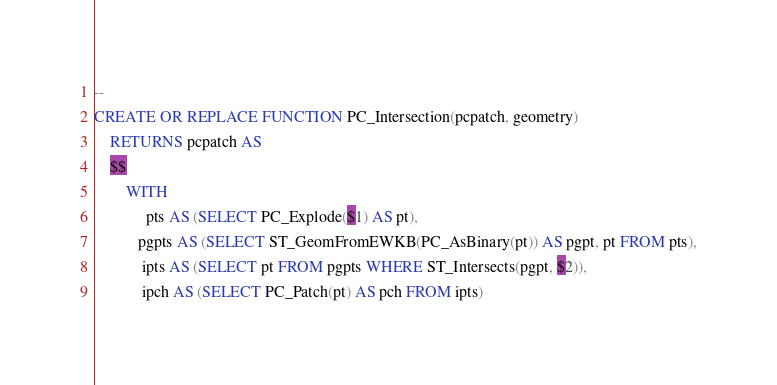<code> <loc_0><loc_0><loc_500><loc_500><_SQL_>--
CREATE OR REPLACE FUNCTION PC_Intersection(pcpatch, geometry)
    RETURNS pcpatch AS
    $$
        WITH 
             pts AS (SELECT PC_Explode($1) AS pt), 
           pgpts AS (SELECT ST_GeomFromEWKB(PC_AsBinary(pt)) AS pgpt, pt FROM pts),
            ipts AS (SELECT pt FROM pgpts WHERE ST_Intersects(pgpt, $2)),
            ipch AS (SELECT PC_Patch(pt) AS pch FROM ipts)</code> 